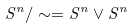Convert formula to latex. <formula><loc_0><loc_0><loc_500><loc_500>S ^ { n } / \sim = S ^ { n } \vee S ^ { n }</formula> 